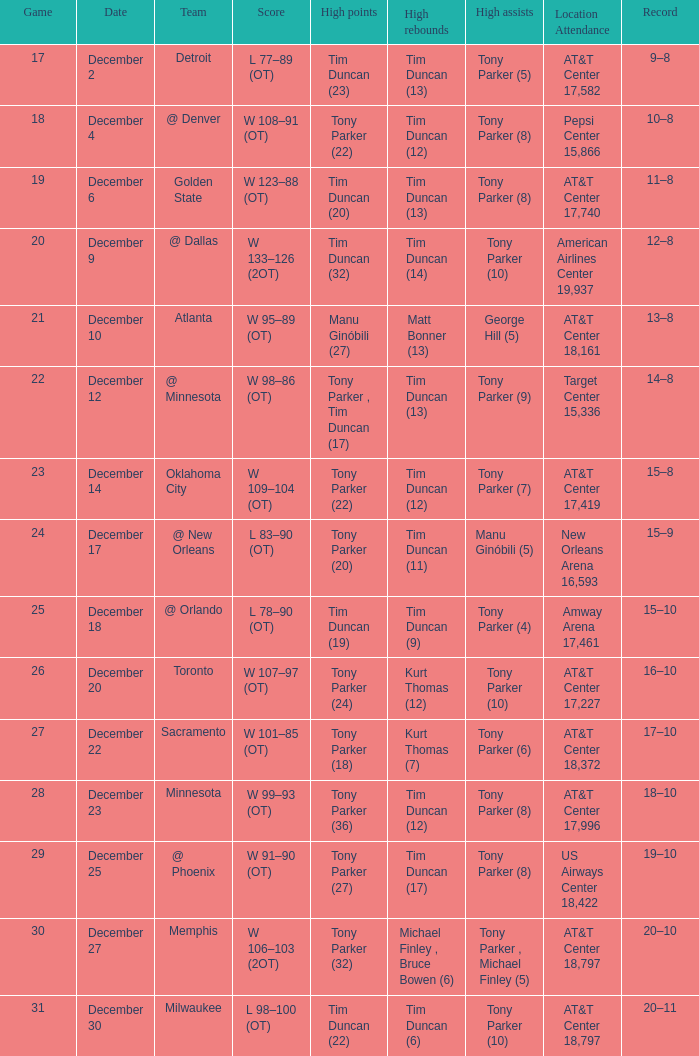What is tim duncan's highest rebound score (14)? W 133–126 (2OT). 